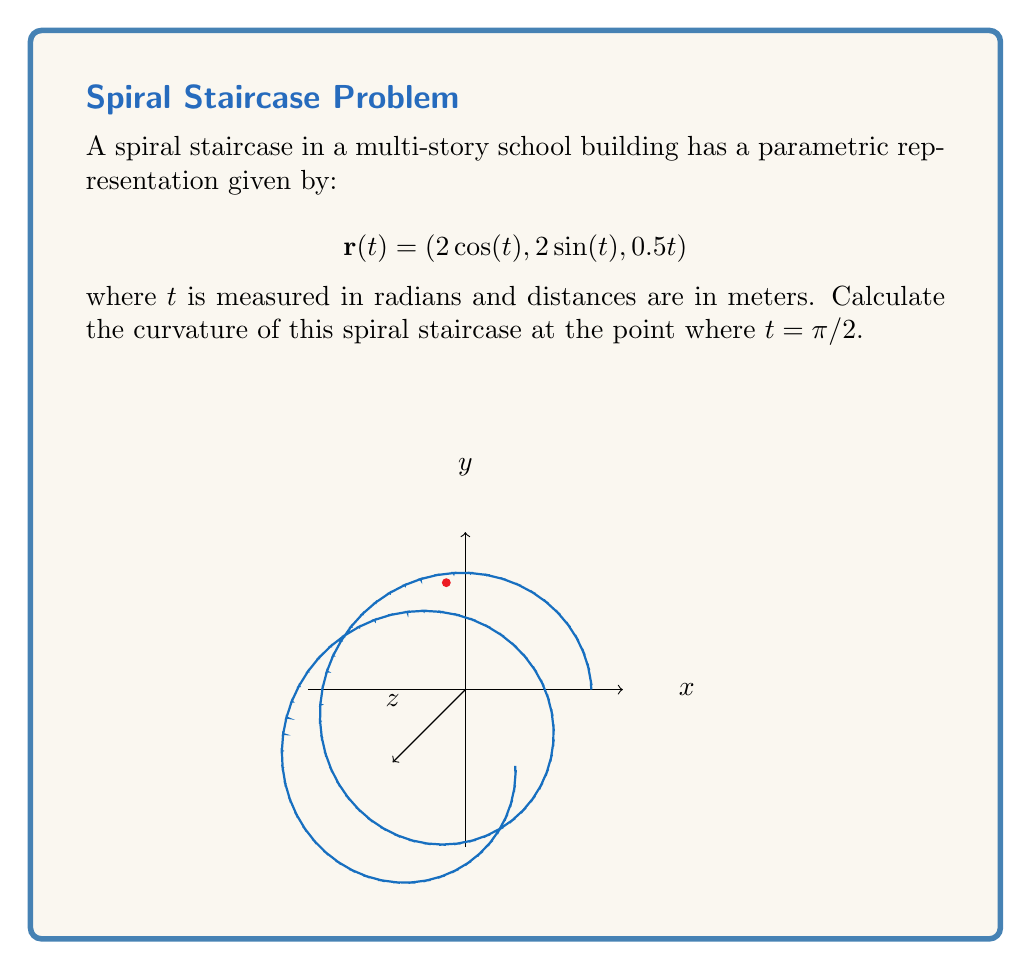Teach me how to tackle this problem. To find the curvature of the spiral staircase, we'll follow these steps:

1) The curvature formula for a vector-valued function is:

   $$\kappa = \frac{|\mathbf{r}'(t) \times \mathbf{r}''(t)|}{|\mathbf{r}'(t)|^3}$$

2) First, let's calculate $\mathbf{r}'(t)$:
   $$\mathbf{r}'(t) = (-2\sin(t), 2\cos(t), 0.5)$$

3) Now, let's calculate $\mathbf{r}''(t)$:
   $$\mathbf{r}''(t) = (-2\cos(t), -2\sin(t), 0)$$

4) At $t = \pi/2$:
   $$\mathbf{r}'(\pi/2) = (-2, 0, 0.5)$$
   $$\mathbf{r}''(\pi/2) = (0, -2, 0)$$

5) Calculate the cross product $\mathbf{r}'(\pi/2) \times \mathbf{r}''(\pi/2)$:
   $$\mathbf{r}'(\pi/2) \times \mathbf{r}''(\pi/2) = (1, -4, -4)$$

6) Calculate $|\mathbf{r}'(\pi/2) \times \mathbf{r}''(\pi/2)|$:
   $$|\mathbf{r}'(\pi/2) \times \mathbf{r}''(\pi/2)| = \sqrt{1^2 + (-4)^2 + (-4)^2} = \sqrt{33}$$

7) Calculate $|\mathbf{r}'(\pi/2)|^3$:
   $$|\mathbf{r}'(\pi/2)|^3 = ((-2)^2 + 0^2 + 0.5^2)^{3/2} = (4.25)^{3/2}$$

8) Finally, calculate the curvature:
   $$\kappa = \frac{\sqrt{33}}{(4.25)^{3/2}} \approx 0.3778$$

Therefore, the curvature of the spiral staircase at $t = \pi/2$ is approximately 0.3778 m^(-1).
Answer: $\kappa \approx 0.3778$ m^(-1) 